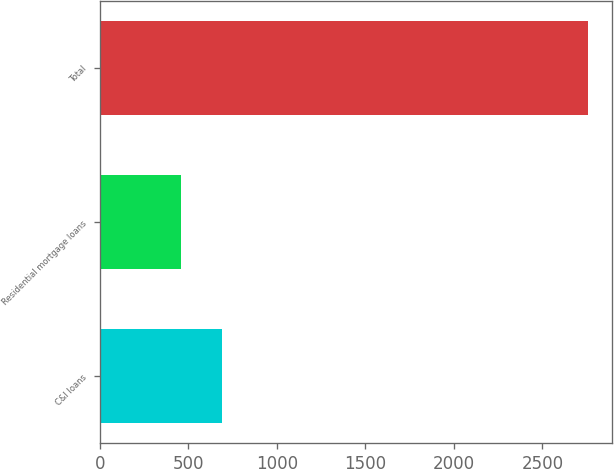Convert chart. <chart><loc_0><loc_0><loc_500><loc_500><bar_chart><fcel>C&I loans<fcel>Residential mortgage loans<fcel>Total<nl><fcel>690.6<fcel>461<fcel>2757<nl></chart> 